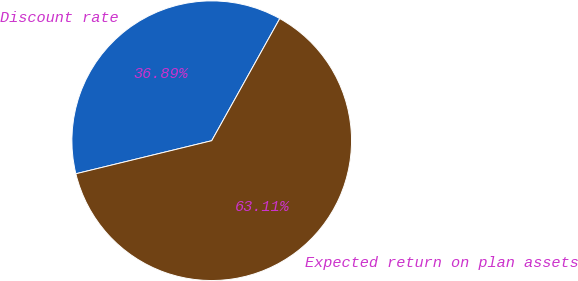<chart> <loc_0><loc_0><loc_500><loc_500><pie_chart><fcel>Discount rate<fcel>Expected return on plan assets<nl><fcel>36.89%<fcel>63.11%<nl></chart> 